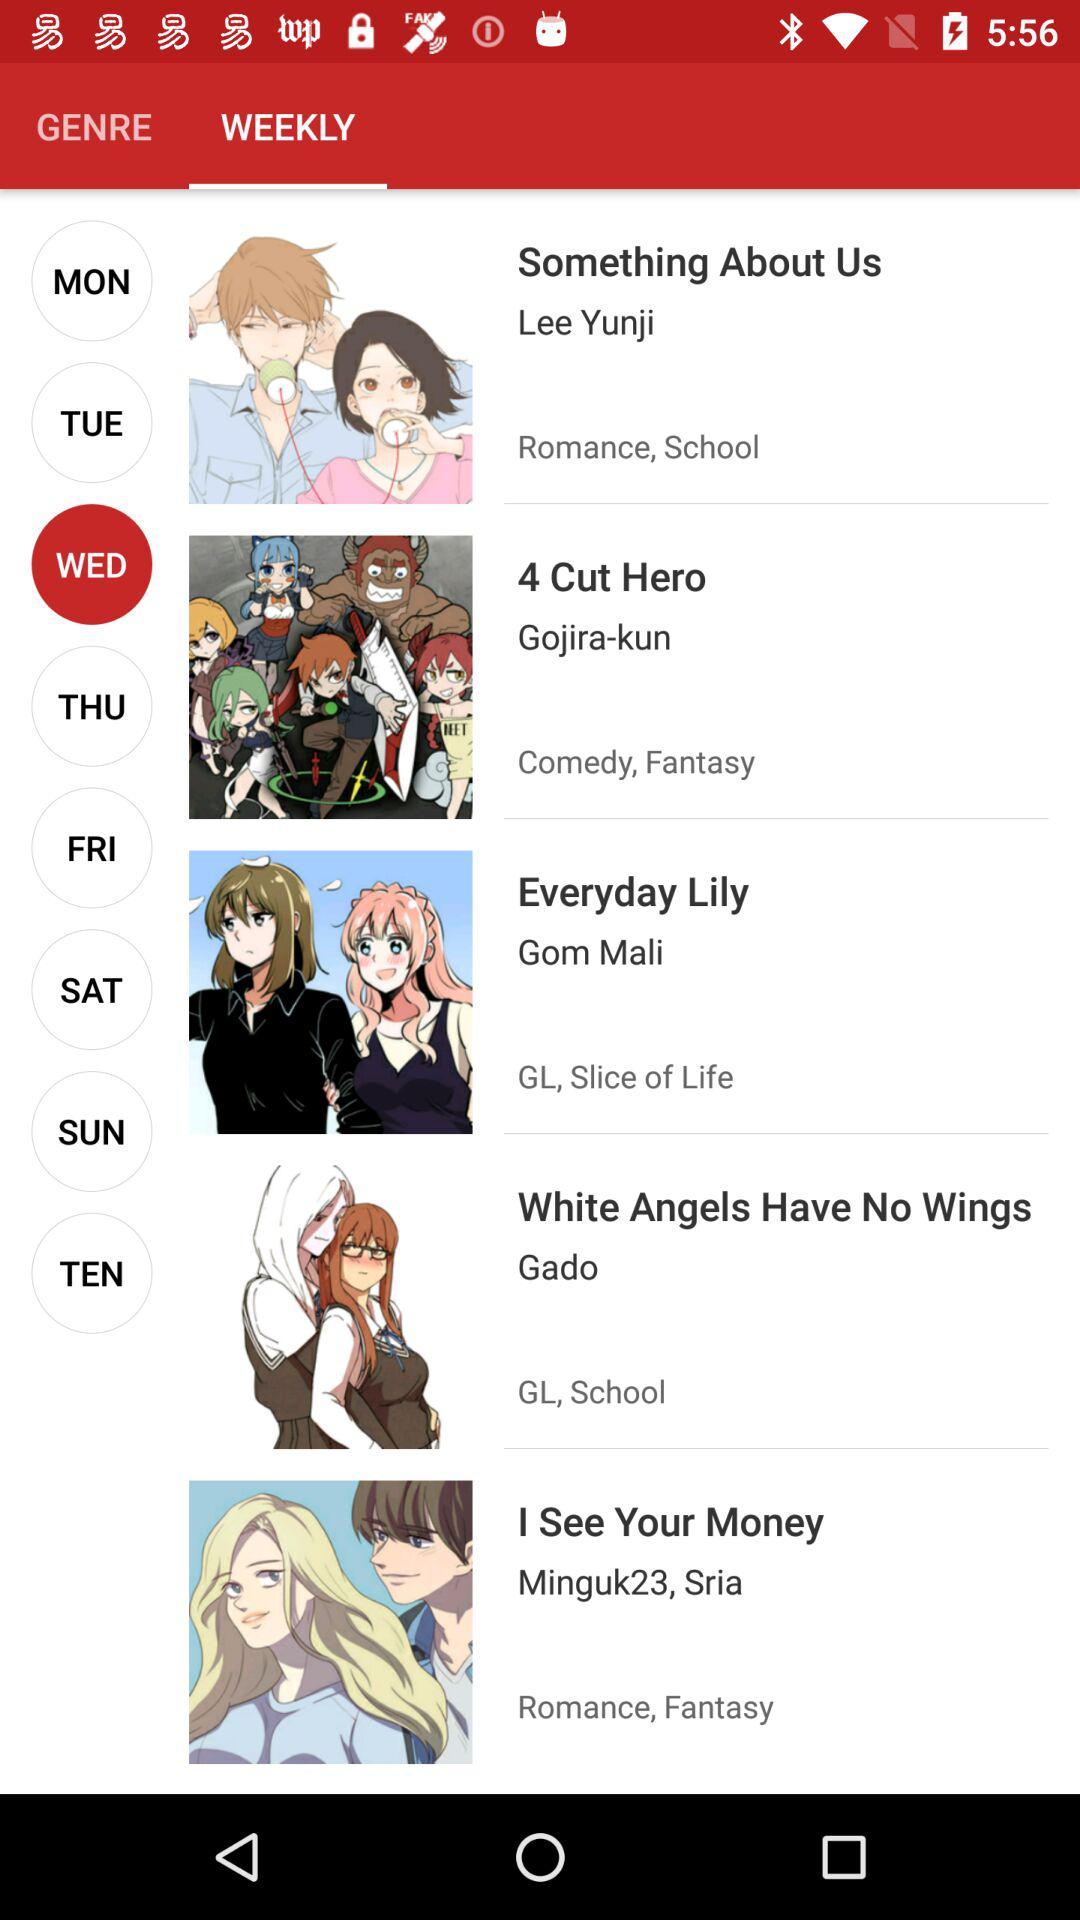What is the genre of "I See Your Money"? The genres are romance and fantasy. 